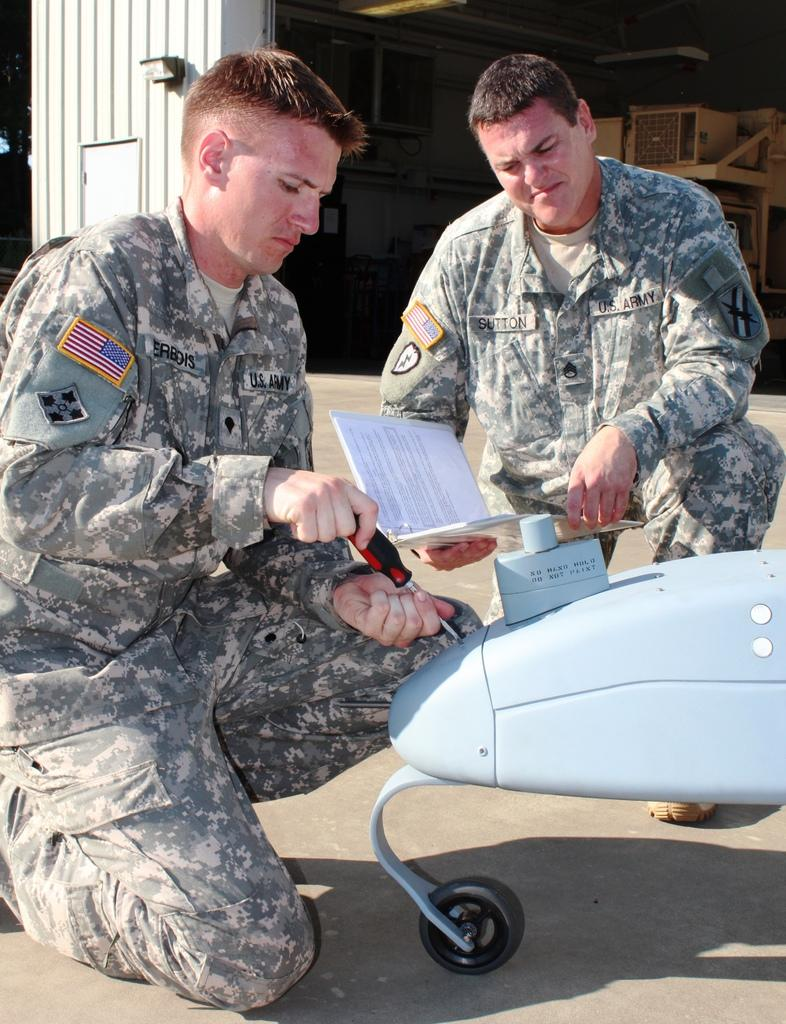How many people are in the image? There are two persons in the center of the image. What can be seen at the right side of the image? There is an object at the right side of the image. What is visible in the background of the image? There is a wall in the background of the image. What type of leg is visible in the image? There is no leg visible in the image. How many quarters are present in the image? There is no mention of quarters in the image, so it cannot be determined if any are present. 